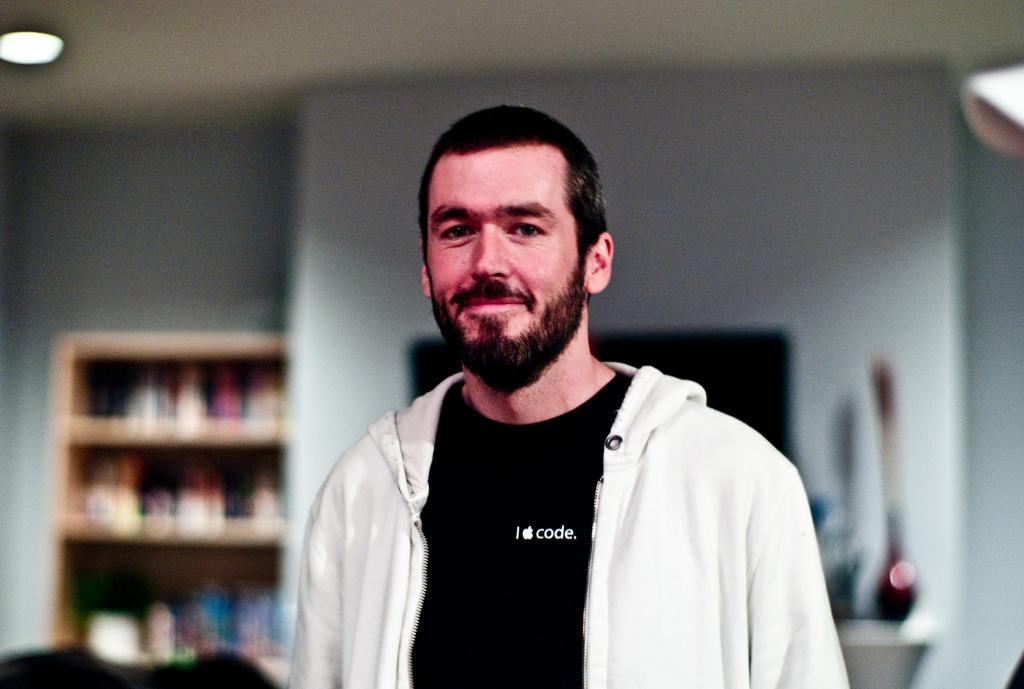<image>
Create a compact narrative representing the image presented. a man with the word code on his shirt 